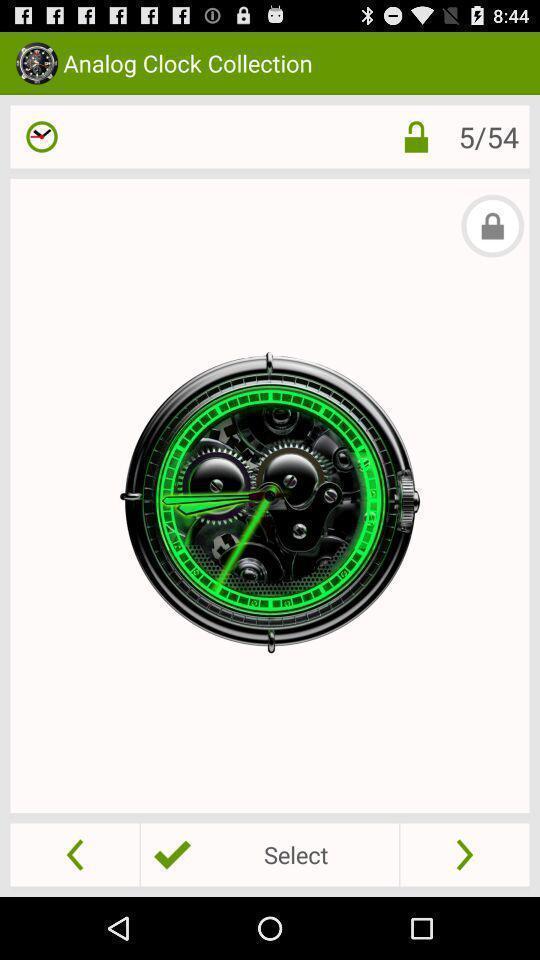Provide a textual representation of this image. Page showing watches in the clock buying app. 